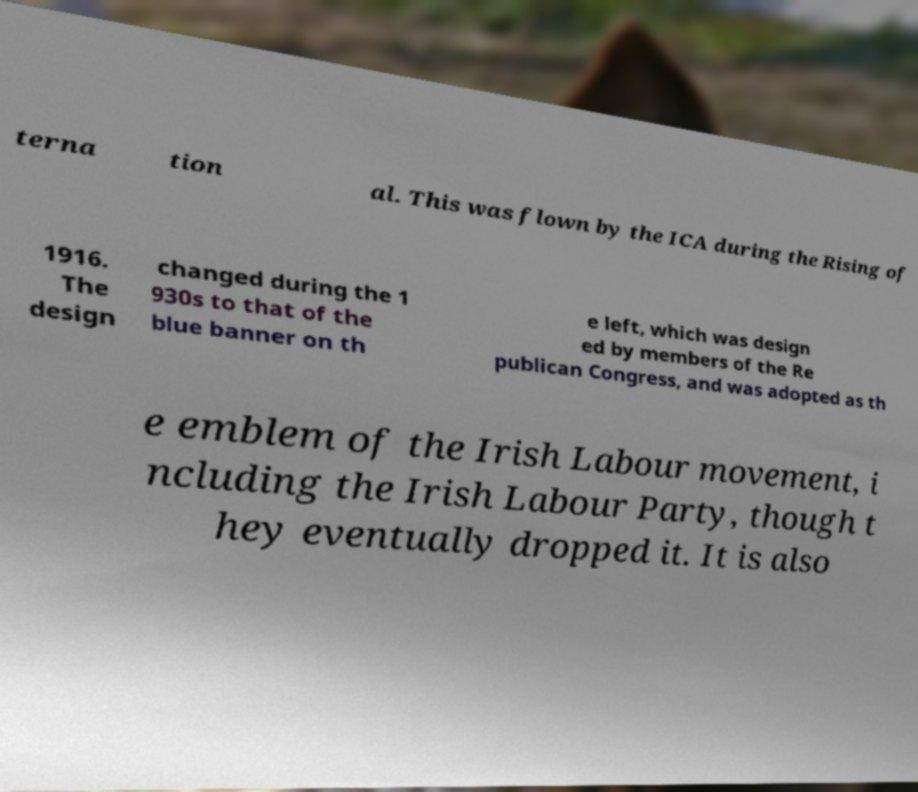I need the written content from this picture converted into text. Can you do that? terna tion al. This was flown by the ICA during the Rising of 1916. The design changed during the 1 930s to that of the blue banner on th e left, which was design ed by members of the Re publican Congress, and was adopted as th e emblem of the Irish Labour movement, i ncluding the Irish Labour Party, though t hey eventually dropped it. It is also 